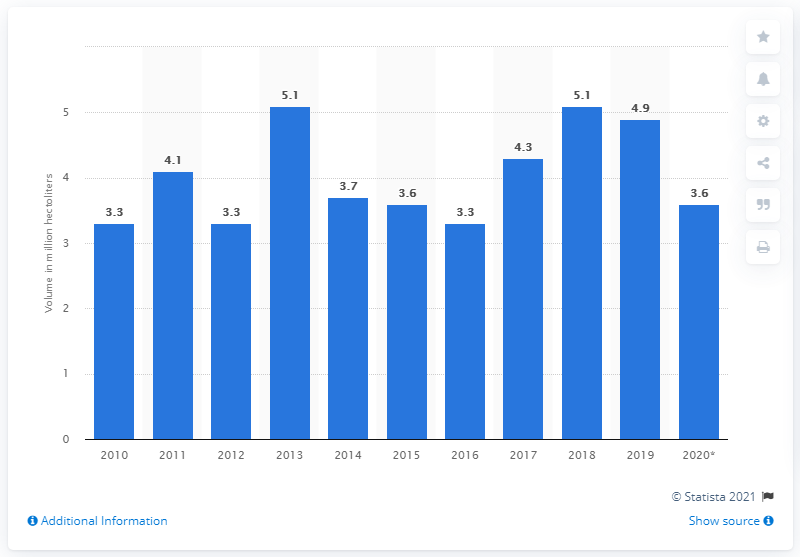Identify some key points in this picture. In 2019, Romania achieved the largest recorded vineyard surface. The total volume of wine produced in Romania between 2013 and 2018 was approximately 5.1 million hectoliters. In 2020, Romania produced approximately 3.6 hectoliters of wine. 